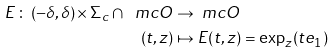Convert formula to latex. <formula><loc_0><loc_0><loc_500><loc_500>E \, \colon \, ( - \delta , \delta ) \times \Sigma _ { c } \cap \ m c O & \rightarrow \ m c O \\ ( t , z ) & \mapsto E ( t , z ) = \exp _ { z } ( t e _ { 1 } )</formula> 